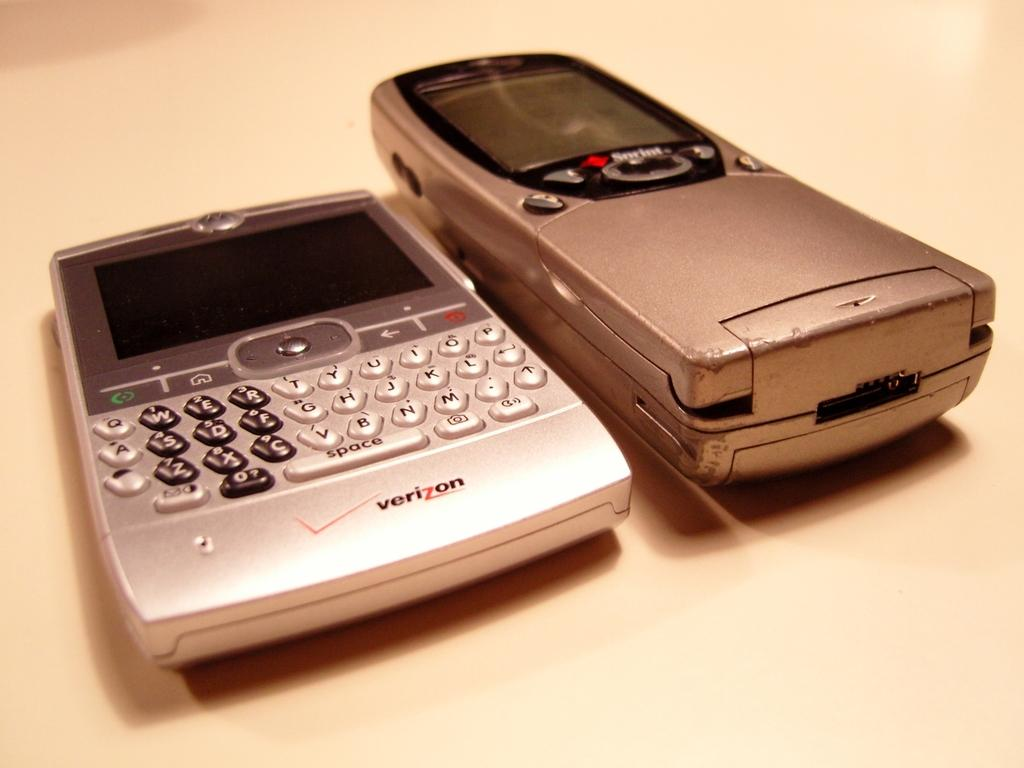<image>
Relay a brief, clear account of the picture shown. A verizon phone next to a sprint flip phone. 